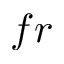<formula> <loc_0><loc_0><loc_500><loc_500>f r</formula> 